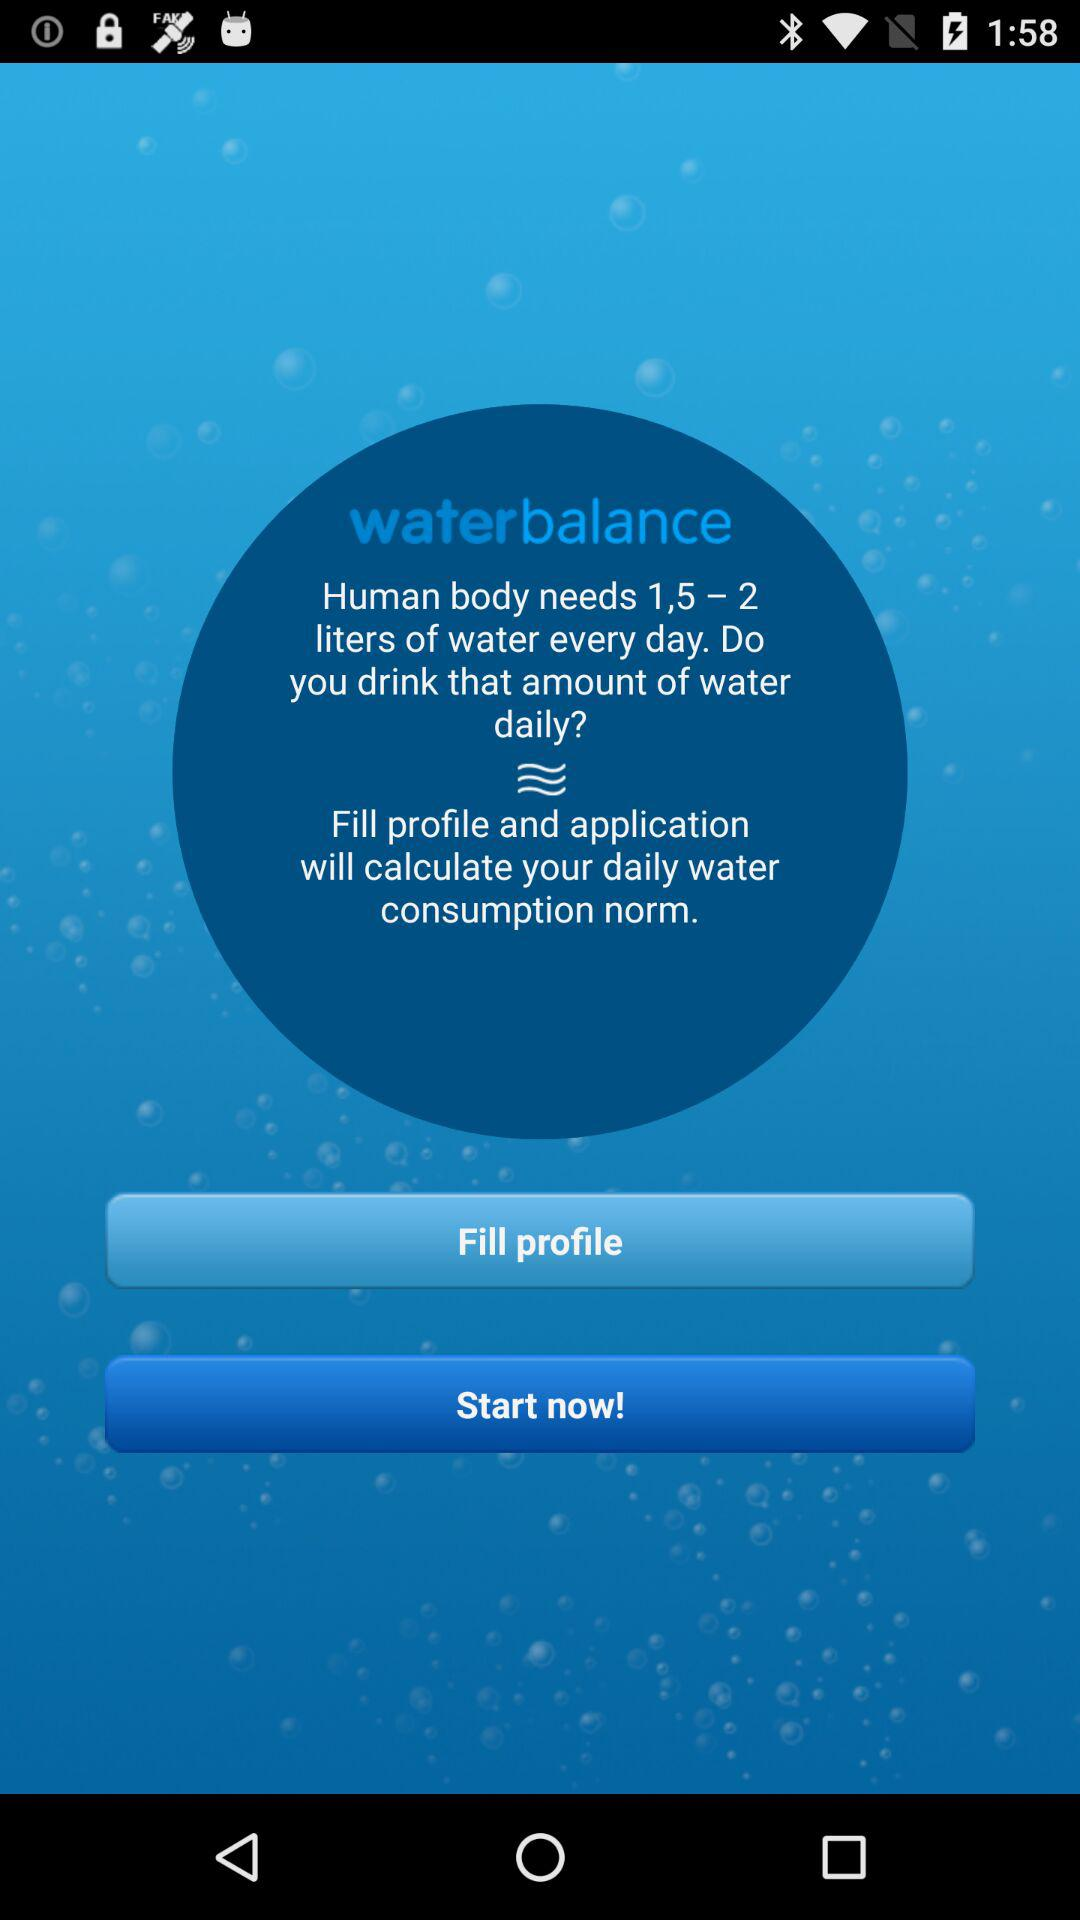How much did the user drink yesterday?
When the provided information is insufficient, respond with <no answer>. <no answer> 